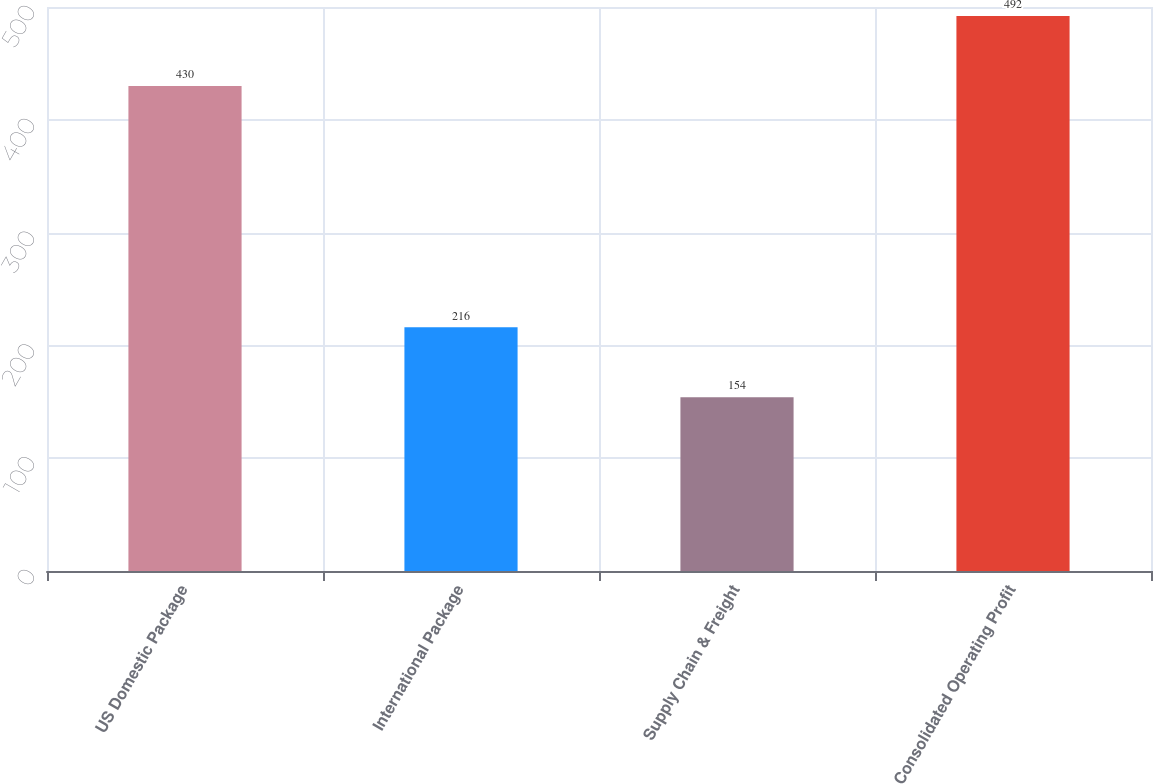Convert chart. <chart><loc_0><loc_0><loc_500><loc_500><bar_chart><fcel>US Domestic Package<fcel>International Package<fcel>Supply Chain & Freight<fcel>Consolidated Operating Profit<nl><fcel>430<fcel>216<fcel>154<fcel>492<nl></chart> 